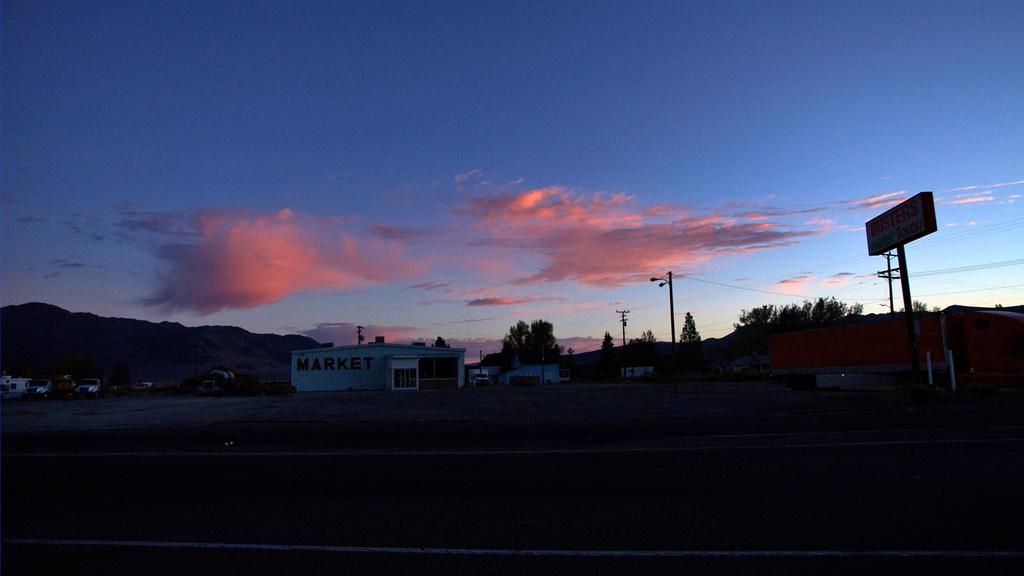What type of pathway is visible in the image? There is a road in the image. What can be seen on the side of the road? There is a hoarding and poles in the image. What type of structures are present in the image? There are houses in the image. What is moving along the road? There are vehicles in the image. What type of vegetation is present in the image? There are trees in the image. What can be seen in the distance in the image? There are hills visible in the background of the image. What is visible above the hills? There is sky visible in the background of the image. What can be seen in the sky? There are clouds in the sky. Where are the flowers planted in the image? There are no flowers present in the image. What type of amphibians can be seen hopping on the road in the image? There are no frogs present in the image. 